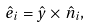Convert formula to latex. <formula><loc_0><loc_0><loc_500><loc_500>\hat { e } _ { i } = \hat { y } \times \hat { n } _ { i } ,</formula> 